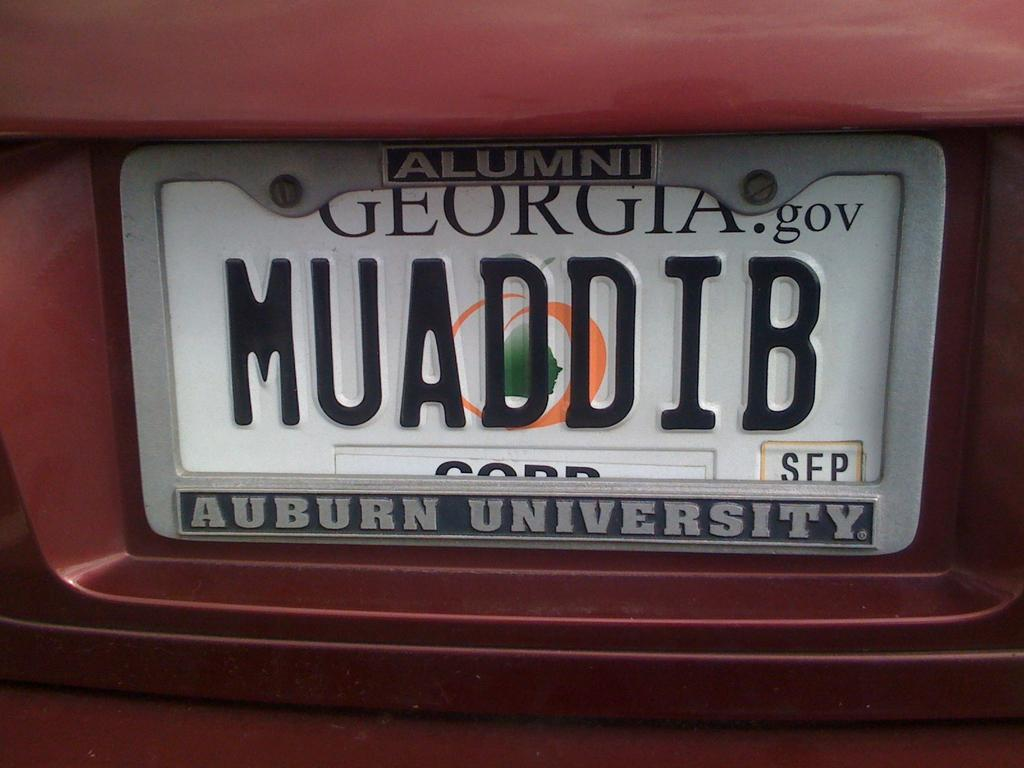<image>
Write a terse but informative summary of the picture. A license plate for the state of Georgia that has Auburn University on it. 